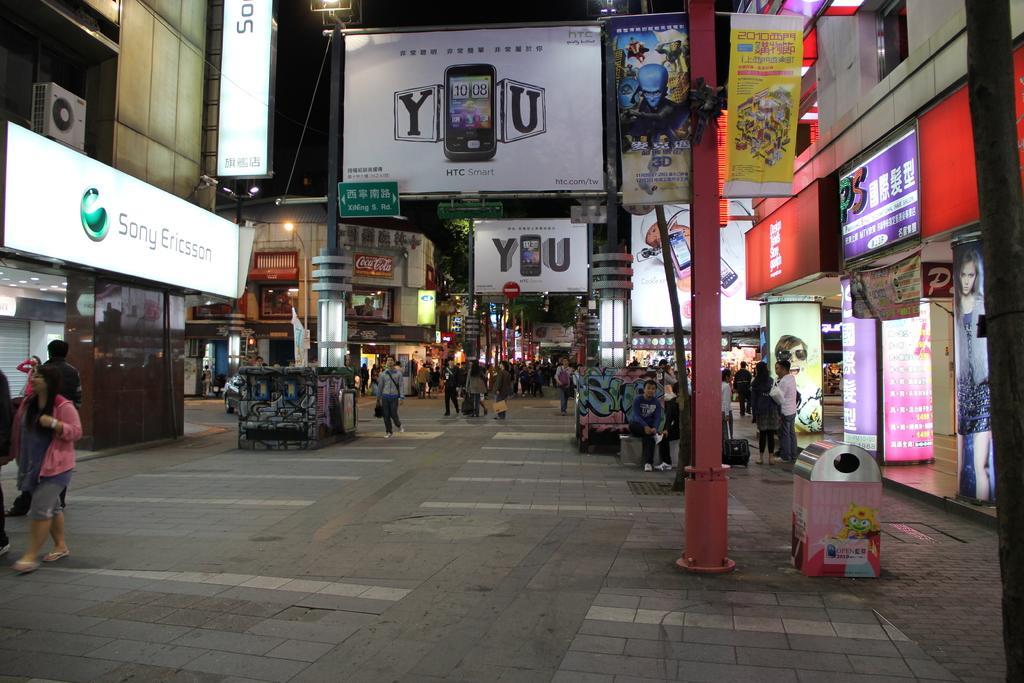Describe this image in one or two sentences. There are people present on the road as we can see at the bottom of this image. We can see poles and a dustbin on the right side of this image. There are buildings, lights and posters in the background. 